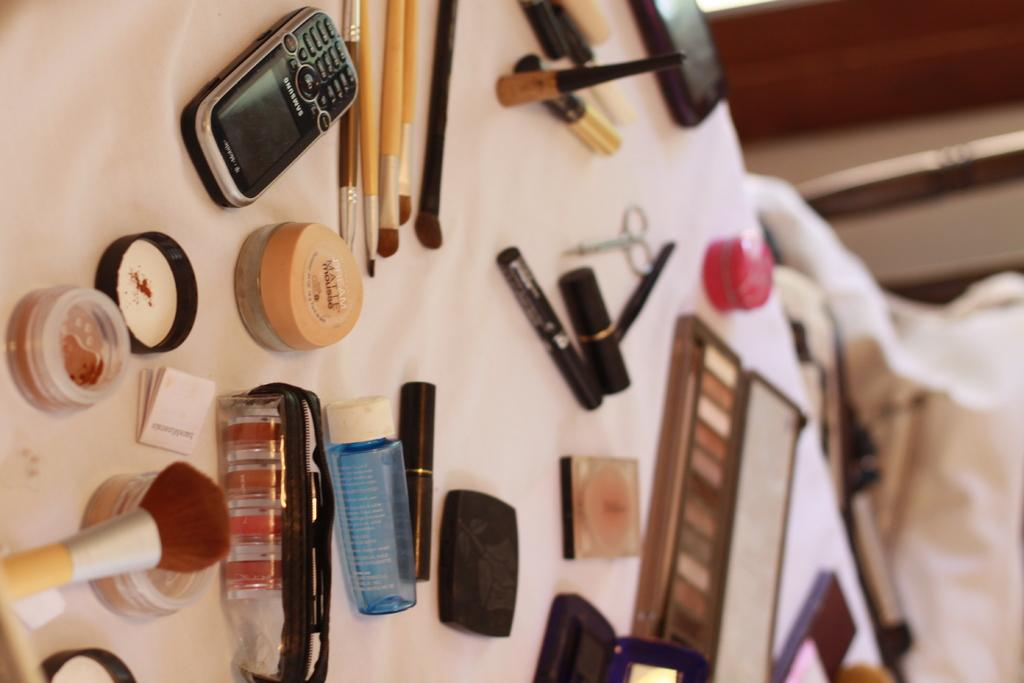<image>
Provide a brief description of the given image. A pile of cosmetics on a bed, one of which reads Dream Matte. 